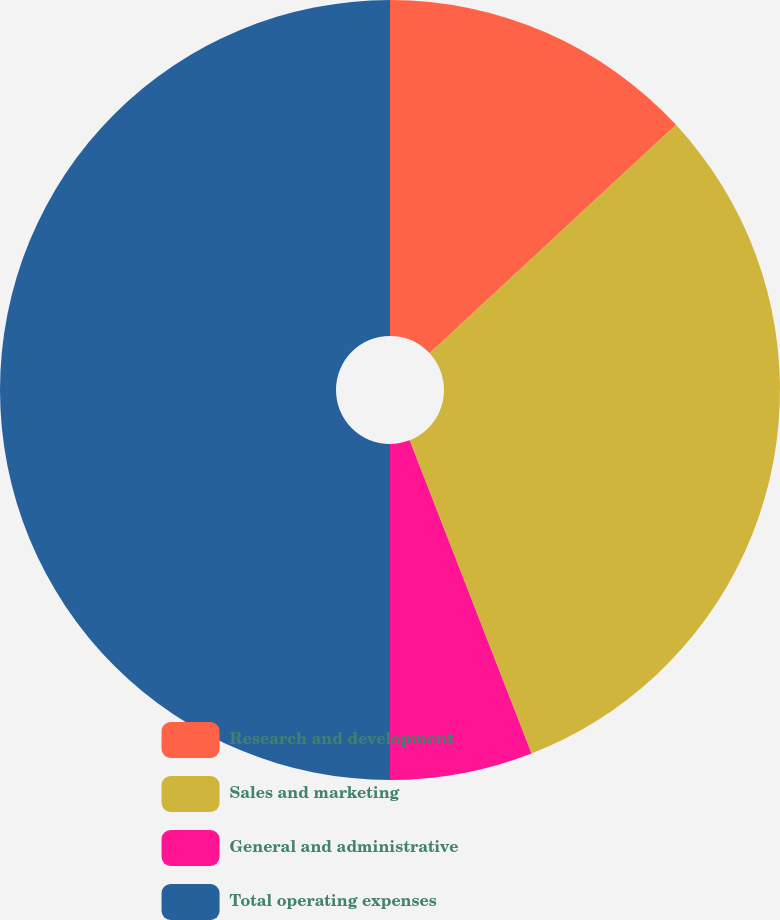Convert chart. <chart><loc_0><loc_0><loc_500><loc_500><pie_chart><fcel>Research and development<fcel>Sales and marketing<fcel>General and administrative<fcel>Total operating expenses<nl><fcel>13.1%<fcel>30.99%<fcel>5.91%<fcel>50.0%<nl></chart> 